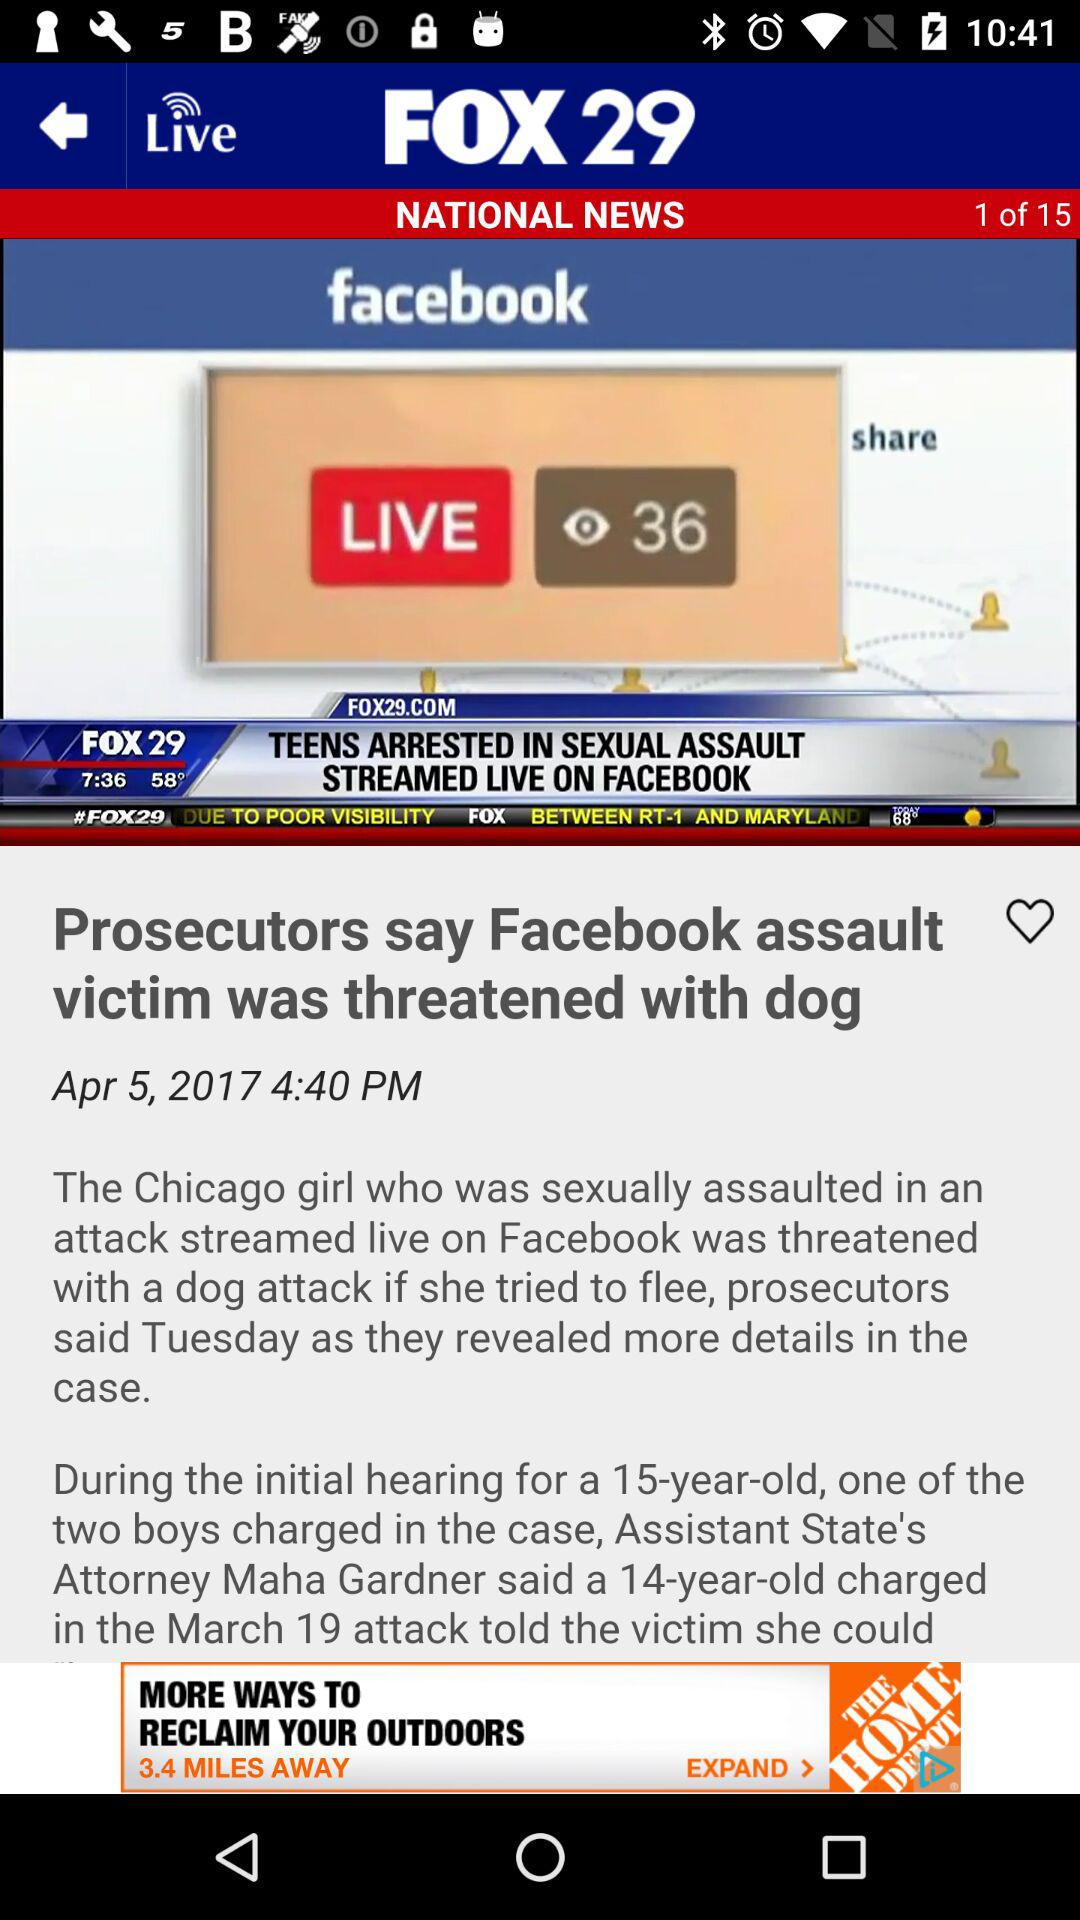What is the date of the attack? The date of the attack is March 19. 